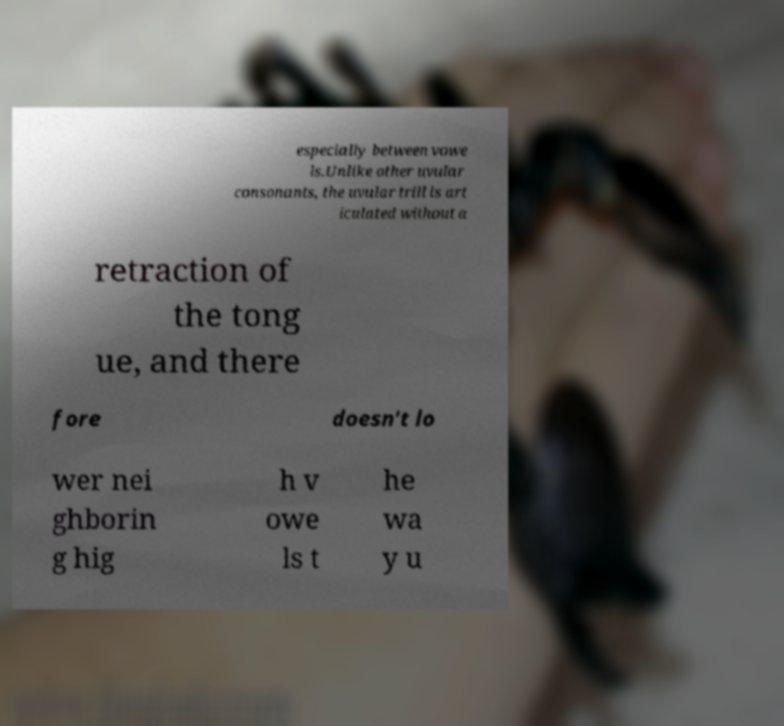There's text embedded in this image that I need extracted. Can you transcribe it verbatim? especially between vowe ls.Unlike other uvular consonants, the uvular trill is art iculated without a retraction of the tong ue, and there fore doesn't lo wer nei ghborin g hig h v owe ls t he wa y u 